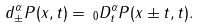<formula> <loc_0><loc_0><loc_500><loc_500>d _ { \pm } ^ { \alpha } P ( x , t ) = \, _ { 0 } D _ { t } ^ { \alpha } P ( x \pm t , t ) .</formula> 